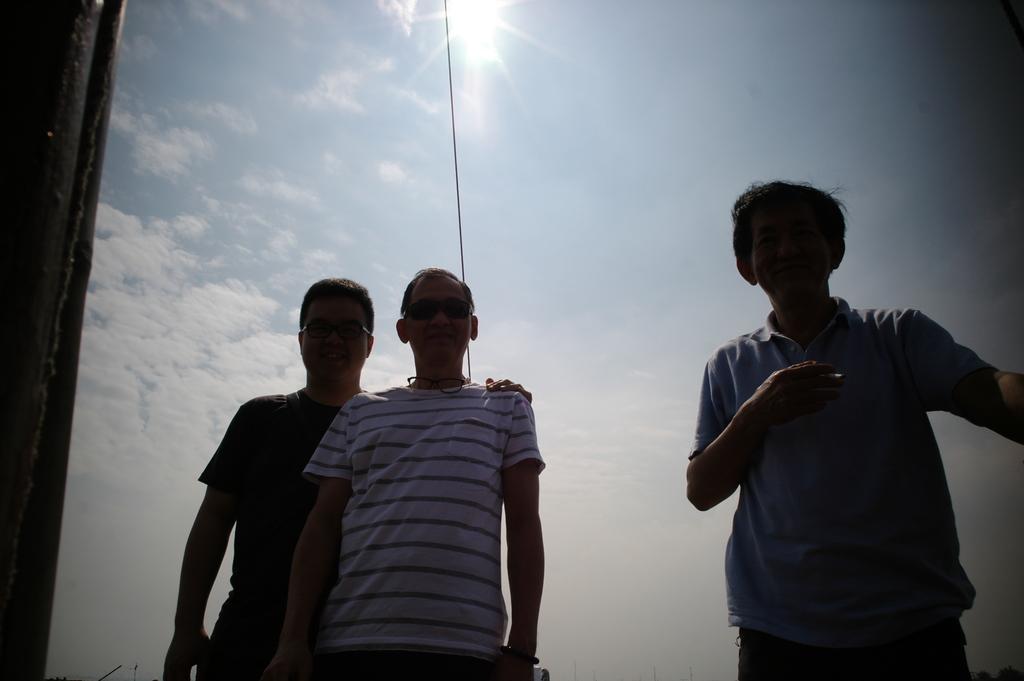Describe this image in one or two sentences. This picture describes about group of people, few people wore spectacles, in the background we can see clouds, cable and the sun. 